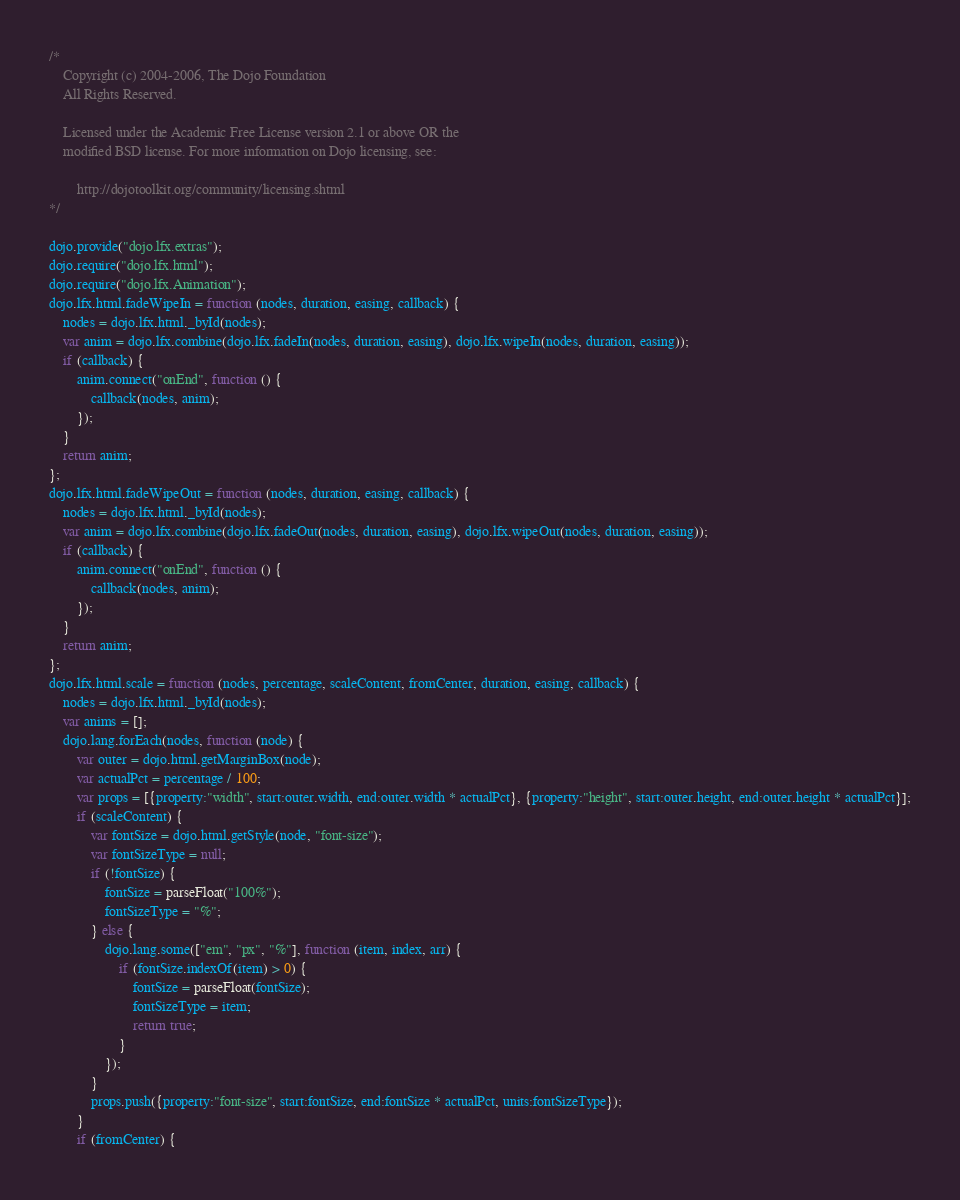Convert code to text. <code><loc_0><loc_0><loc_500><loc_500><_JavaScript_>/*
	Copyright (c) 2004-2006, The Dojo Foundation
	All Rights Reserved.

	Licensed under the Academic Free License version 2.1 or above OR the
	modified BSD license. For more information on Dojo licensing, see:

		http://dojotoolkit.org/community/licensing.shtml
*/

dojo.provide("dojo.lfx.extras");
dojo.require("dojo.lfx.html");
dojo.require("dojo.lfx.Animation");
dojo.lfx.html.fadeWipeIn = function (nodes, duration, easing, callback) {
	nodes = dojo.lfx.html._byId(nodes);
	var anim = dojo.lfx.combine(dojo.lfx.fadeIn(nodes, duration, easing), dojo.lfx.wipeIn(nodes, duration, easing));
	if (callback) {
		anim.connect("onEnd", function () {
			callback(nodes, anim);
		});
	}
	return anim;
};
dojo.lfx.html.fadeWipeOut = function (nodes, duration, easing, callback) {
	nodes = dojo.lfx.html._byId(nodes);
	var anim = dojo.lfx.combine(dojo.lfx.fadeOut(nodes, duration, easing), dojo.lfx.wipeOut(nodes, duration, easing));
	if (callback) {
		anim.connect("onEnd", function () {
			callback(nodes, anim);
		});
	}
	return anim;
};
dojo.lfx.html.scale = function (nodes, percentage, scaleContent, fromCenter, duration, easing, callback) {
	nodes = dojo.lfx.html._byId(nodes);
	var anims = [];
	dojo.lang.forEach(nodes, function (node) {
		var outer = dojo.html.getMarginBox(node);
		var actualPct = percentage / 100;
		var props = [{property:"width", start:outer.width, end:outer.width * actualPct}, {property:"height", start:outer.height, end:outer.height * actualPct}];
		if (scaleContent) {
			var fontSize = dojo.html.getStyle(node, "font-size");
			var fontSizeType = null;
			if (!fontSize) {
				fontSize = parseFloat("100%");
				fontSizeType = "%";
			} else {
				dojo.lang.some(["em", "px", "%"], function (item, index, arr) {
					if (fontSize.indexOf(item) > 0) {
						fontSize = parseFloat(fontSize);
						fontSizeType = item;
						return true;
					}
				});
			}
			props.push({property:"font-size", start:fontSize, end:fontSize * actualPct, units:fontSizeType});
		}
		if (fromCenter) {</code> 